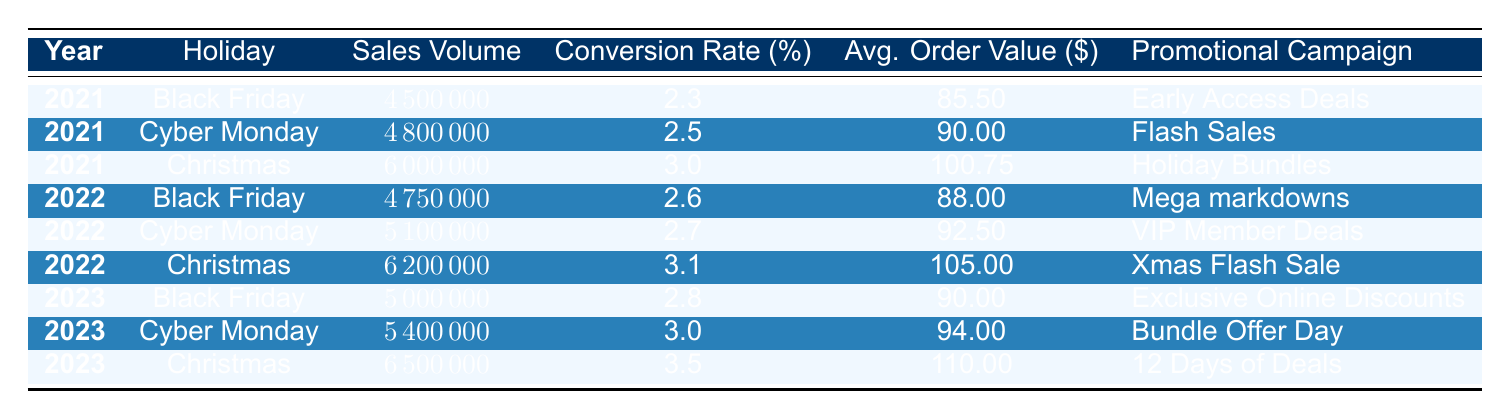What was the highest sales volume during the holiday periods listed? The sales volumes for each holiday period are listed in the table. By comparing the sales volumes, the highest value is 6500000 for Christmas in 2023.
Answer: 6500000 What promotional campaign had a conversion rate of 3.5%? Referring to the conversion rates in the table, the only campaign with a conversion rate of 3.5% is the "12 Days of Deals" from Christmas 2023.
Answer: 12 Days of Deals What is the conversion rate difference between Cyber Monday 2021 and Cyber Monday 2023? The conversion rate for Cyber Monday 2021 is 2.5% and for 2023 is 3.0%. The difference is calculated as 3.0 - 2.5 = 0.5%.
Answer: 0.5 Did the average order value increase from Black Friday 2021 to Black Friday 2023? The average order values for Black Friday 2021 and 2023 are 85.50 and 90.00, respectively. The value increased, thus the answer is yes.
Answer: Yes What was the total sales volume for Christmas across all three years? We sum the sales volumes for Christmas from 2021, 2022, and 2023: 6000000 + 6200000 + 6500000 = 18700000.
Answer: 18700000 Which promotional campaign had the highest average order value? The average order values are analyzed from the table: for Christmas 2023, it's 110.00, which is the highest compared to all other campaigns.
Answer: 12 Days of Deals Is the conversion rate for Black Friday 2022 higher than that of Christmas 2021? The conversion rate for Black Friday 2022 is 2.6% and for Christmas 2021 it is 3.0%. Since 2.6% is less than 3.0%, the answer is no.
Answer: No What was the average order value for all the holiday periods in 2022? The average order values for the holiday periods in 2022 are 88.00 (Black Friday), 92.50 (Cyber Monday), and 105.00 (Christmas). Summing these gives 285.50, and averaging by dividing by 3 yields 285.50 / 3 = 95.17.
Answer: 95.17 What was the sales volume increase from Black Friday 2021 to Black Friday 2023? The sales volume for Black Friday 2021 is 4500000 and for 2023 is 5000000. The increase is calculated as 5000000 - 4500000 = 500000.
Answer: 500000 